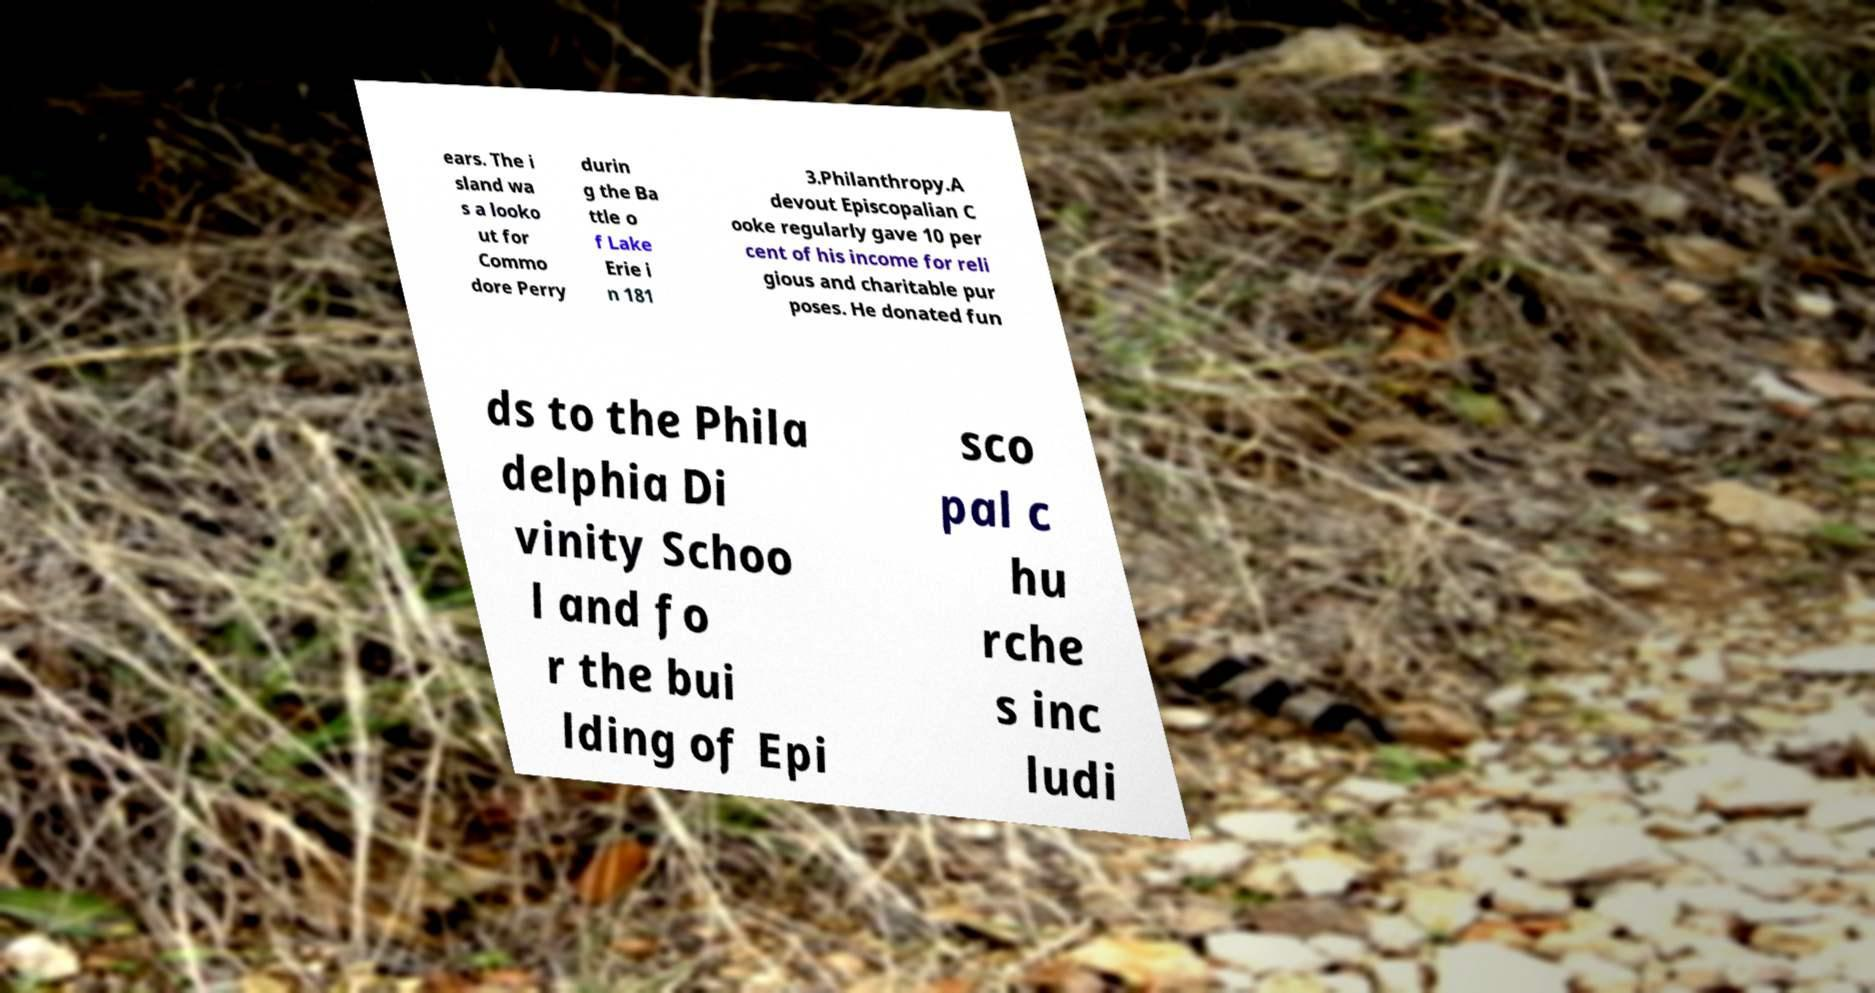Can you read and provide the text displayed in the image?This photo seems to have some interesting text. Can you extract and type it out for me? ears. The i sland wa s a looko ut for Commo dore Perry durin g the Ba ttle o f Lake Erie i n 181 3.Philanthropy.A devout Episcopalian C ooke regularly gave 10 per cent of his income for reli gious and charitable pur poses. He donated fun ds to the Phila delphia Di vinity Schoo l and fo r the bui lding of Epi sco pal c hu rche s inc ludi 